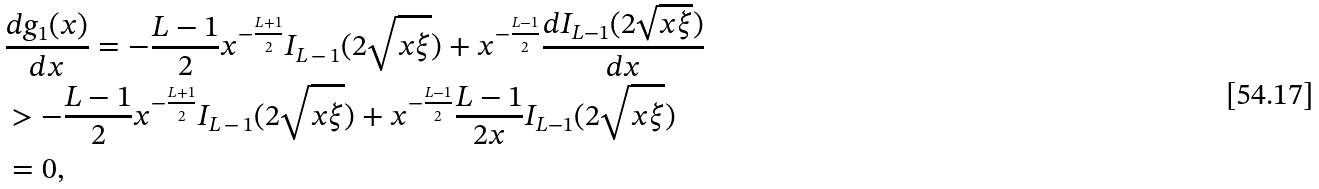Convert formula to latex. <formula><loc_0><loc_0><loc_500><loc_500>& \frac { d g _ { 1 } ( x ) } { d x } = - \frac { L - 1 } { 2 } x ^ { - \frac { L + 1 } { 2 } } I _ { L \, - \, 1 } ( 2 \sqrt { x \xi } ) + x ^ { - \frac { L - 1 } { 2 } } \frac { d I _ { L - 1 } ( 2 \sqrt { x \xi } ) } { d x } \\ & > - \frac { L - 1 } { 2 } x ^ { - \frac { L + 1 } { 2 } } I _ { L \, - \, 1 } ( 2 \sqrt { x \xi } ) + x ^ { - \frac { L - 1 } { 2 } } \frac { L - 1 } { 2 x } I _ { L - 1 } ( 2 \sqrt { x \xi } ) \\ & = 0 ,</formula> 